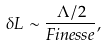<formula> <loc_0><loc_0><loc_500><loc_500>\delta L \sim \frac { \Lambda / 2 } { F i n e s s e } ,</formula> 